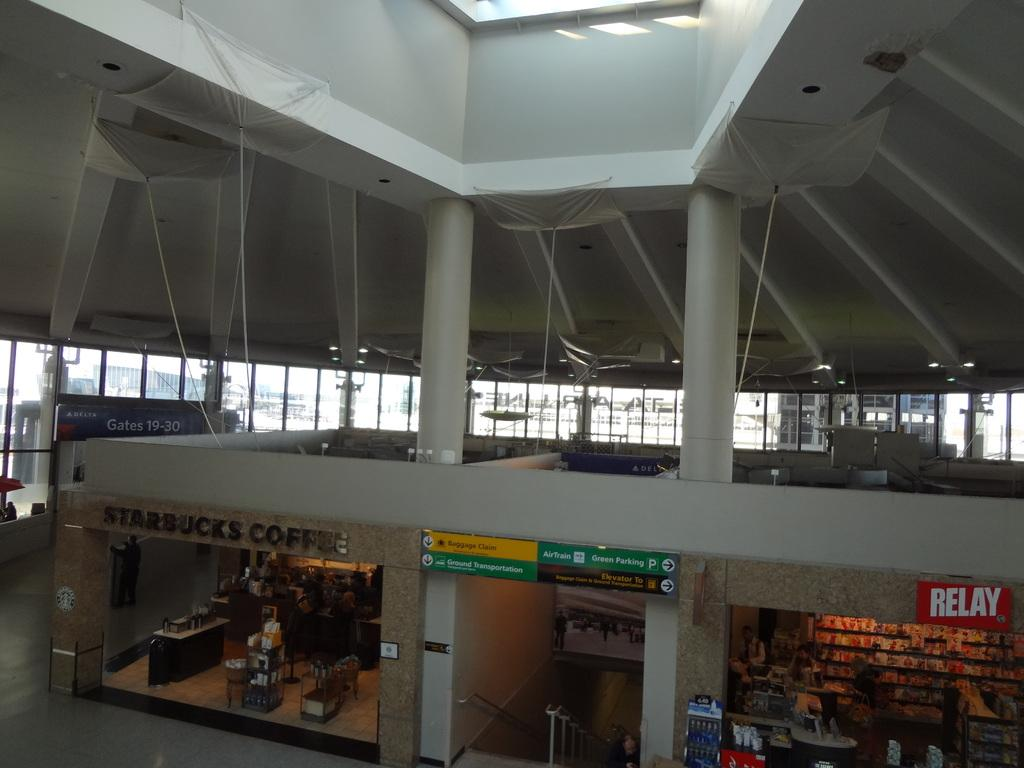What type of establishment is depicted in the image? There is a group of stores in the image. How are the stores arranged in the image? The stores are placed on the floor. What other objects can be seen in the image? There is a group of sign boards in the image. Where are the sign boards located in the image? The sign boards are placed on the wall. What can be seen in the background of the image? There are windows visible in the background of the image. What type of doctor is present in the image? There is no doctor present in the image; it features a group of stores and sign boards. What can be seen in the aftermath of the event in the image? There is no event or aftermath mentioned in the image; it shows a group of stores and sign boards. 